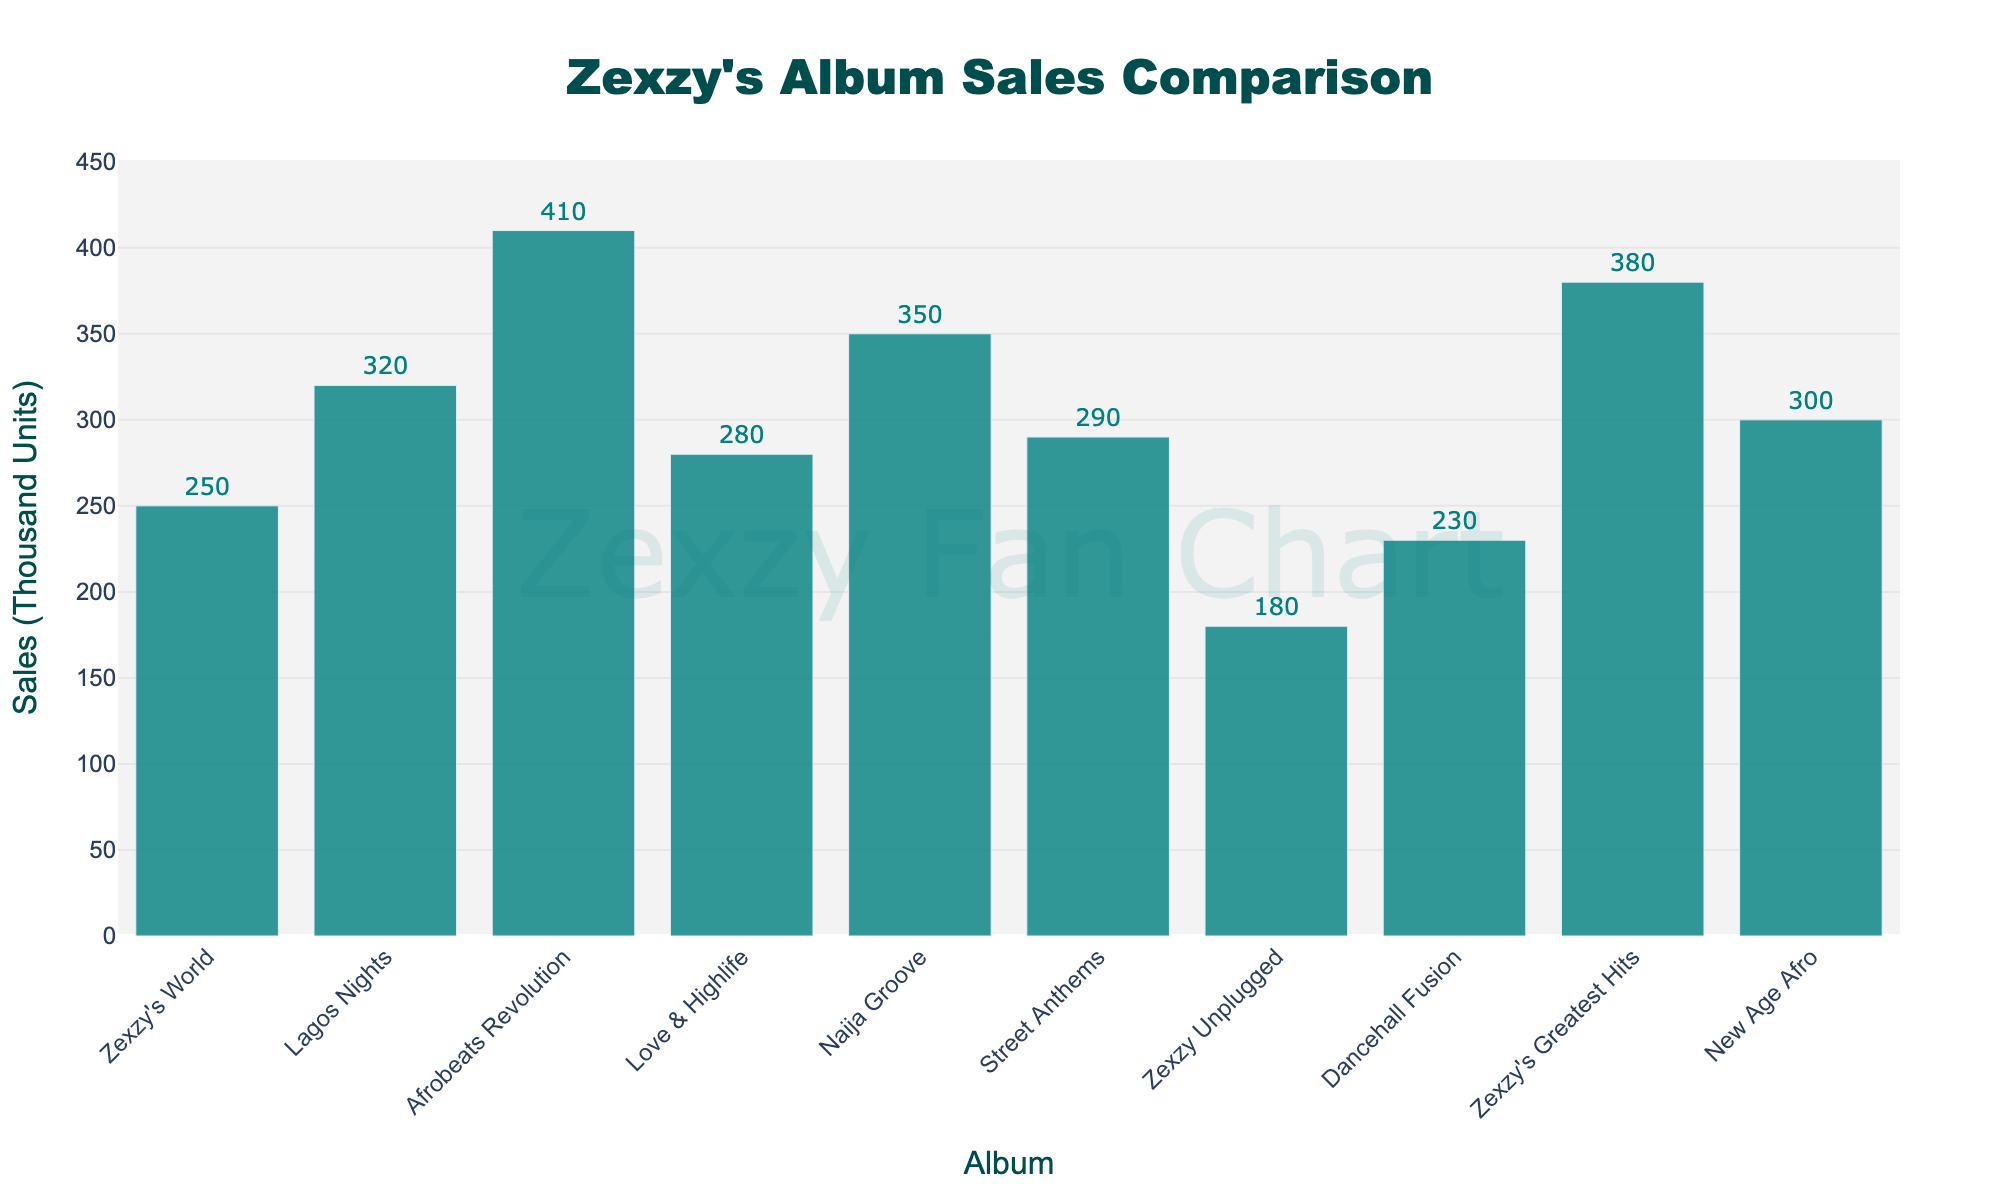What is the album with the highest sales? From the bar chart, we observe the height of each bar to determine sales. The tallest bar represents "Afrobeats Revolution" with sales of 410 thousand units.
Answer: "Afrobeats Revolution" Which album has the lowest sales? From the bar chart, the shortest bar corresponds to "Zexzy Unplugged" with 180 thousand units.
Answer: "Zexzy Unplugged" What is the total sales of "Zexzy's World" and "Zexzy Unplugged"? We sum the sales of "Zexzy's World" (250 thousand units) and "Zexzy Unplugged" (180 thousand units). 250 + 180 = 430 thousand units.
Answer: 430 thousand units How many albums have sales greater than 300 thousand units? Counting the bars representing sales values over 300 thousand units: "Lagos Nights", "Afrobeats Revolution", "Naija Groove", and "Zexzy's Greatest Hits". There are 4 albums.
Answer: 4 Which album has sales closest to 300 thousand units? Reviewing bars around 300 thousand units, "New Age Afro" has sales of exactly 300 thousand units, making it closest to this value.
Answer: "New Age Afro" What is the average sales of all albums? Adding all sales: 250 + 320 + 410 + 280 + 350 + 290 + 180 + 230 + 380 + 300 = 2990 thousand units. Dividing by the number of albums (10), 2990 / 10 = 299 thousand units.
Answer: 299 thousand units By how much do the sales of "Afrobeats Revolution" exceed those of "Love & Highlife"? Subtracting the sales of "Love & Highlife" (280 thousand units) from "Afrobeats Revolution" (410 thousand units): 410 - 280 = 130 thousand units.
Answer: 130 thousand units Rank the albums from highest to lowest sales. Evaluating the bar heights in descending order: "Afrobeats Revolution", "Zexzy's Greatest Hits", "Naija Groove", "Lagos Nights", "New Age Afro", "Love & Highlife", "Street Anthems", "Zexzy's World", "Dancehall Fusion", "Zexzy Unplugged".
Answer: "Afrobeats Revolution", "Zexzy's Greatest Hits", "Naija Groove", "Lagos Nights", "New Age Afro", "Love & Highlife", "Street Anthems", "Zexzy's World", "Dancehall Fusion", "Zexzy Unplugged" What is the difference in sales between the highest and lowest selling albums? The highest selling album "Afrobeats Revolution" has 410 thousand units, and the lowest selling album "Zexzy Unplugged" has 180 thousand units. The difference is 410 - 180 = 230 thousand units.
Answer: 230 thousand units What is the median sales value for the albums? Ordering the sales values: 180, 230, 250, 280, 290, 300, 320, 350, 380, 410. The median (middle) values are 290 and 300, and the average of these two is (290 + 300) / 2 = 295 thousand units.
Answer: 295 thousand units 